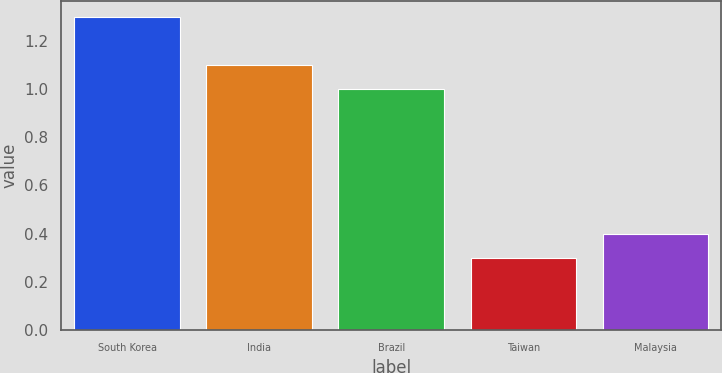<chart> <loc_0><loc_0><loc_500><loc_500><bar_chart><fcel>South Korea<fcel>India<fcel>Brazil<fcel>Taiwan<fcel>Malaysia<nl><fcel>1.3<fcel>1.1<fcel>1<fcel>0.3<fcel>0.4<nl></chart> 